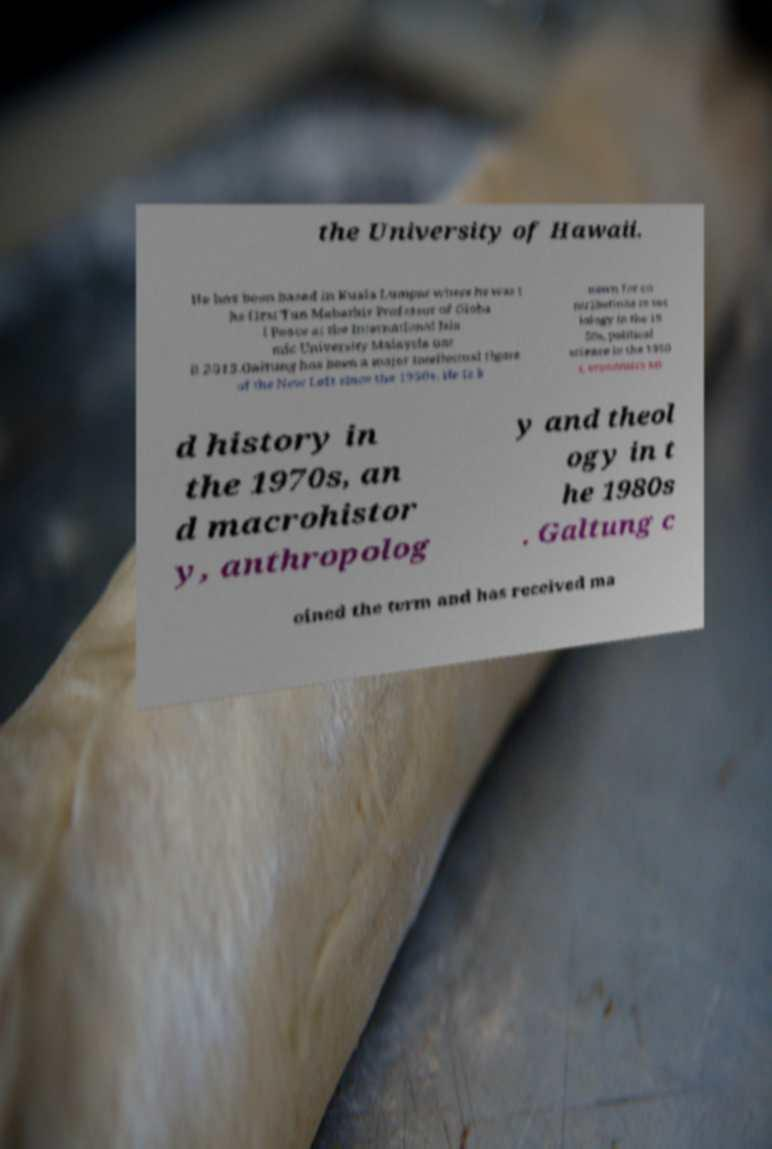Please identify and transcribe the text found in this image. the University of Hawaii. He has been based in Kuala Lumpur where he was t he first Tun Mahathir Professor of Globa l Peace at the International Isla mic University Malaysia unt il 2015.Galtung has been a major intellectual figure of the New Left since the 1950s. He is k nown for co ntributions to soc iology in the 19 50s, political science in the 1960 s, economics an d history in the 1970s, an d macrohistor y, anthropolog y and theol ogy in t he 1980s . Galtung c oined the term and has received ma 